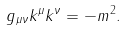<formula> <loc_0><loc_0><loc_500><loc_500>g _ { \mu \nu } k ^ { \mu } k ^ { \nu } = - m ^ { 2 } .</formula> 